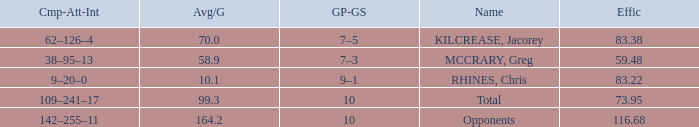Give me the full table as a dictionary. {'header': ['Cmp-Att-Int', 'Avg/G', 'GP-GS', 'Name', 'Effic'], 'rows': [['62–126–4', '70.0', '7–5', 'KILCREASE, Jacorey', '83.38'], ['38–95–13', '58.9', '7–3', 'MCCRARY, Greg', '59.48'], ['9–20–0', '10.1', '9–1', 'RHINES, Chris', '83.22'], ['109–241–17', '99.3', '10', 'Total', '73.95'], ['142–255–11', '164.2', '10', 'Opponents', '116.68']]} What is the total avg/g of McCrary, Greg? 1.0. 